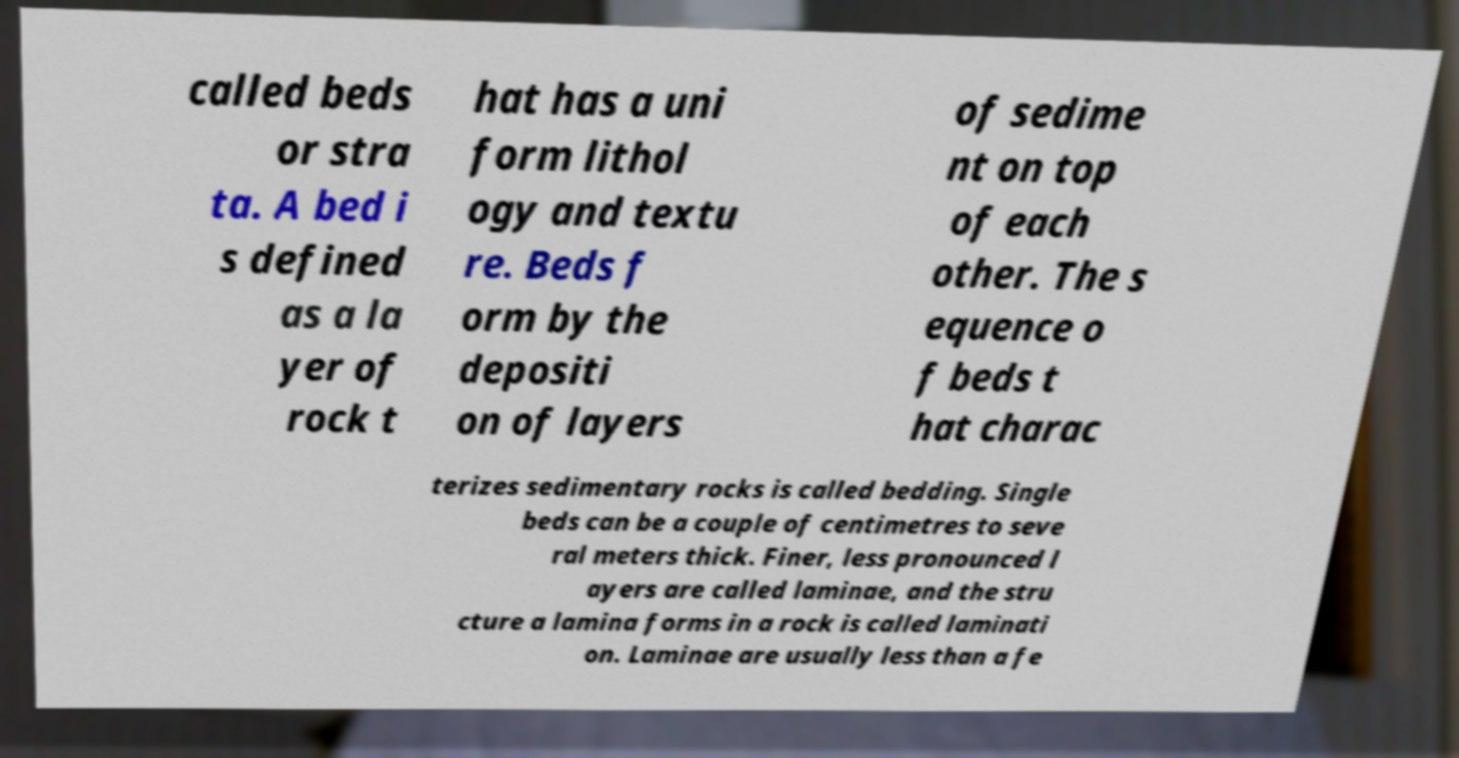Can you read and provide the text displayed in the image?This photo seems to have some interesting text. Can you extract and type it out for me? called beds or stra ta. A bed i s defined as a la yer of rock t hat has a uni form lithol ogy and textu re. Beds f orm by the depositi on of layers of sedime nt on top of each other. The s equence o f beds t hat charac terizes sedimentary rocks is called bedding. Single beds can be a couple of centimetres to seve ral meters thick. Finer, less pronounced l ayers are called laminae, and the stru cture a lamina forms in a rock is called laminati on. Laminae are usually less than a fe 